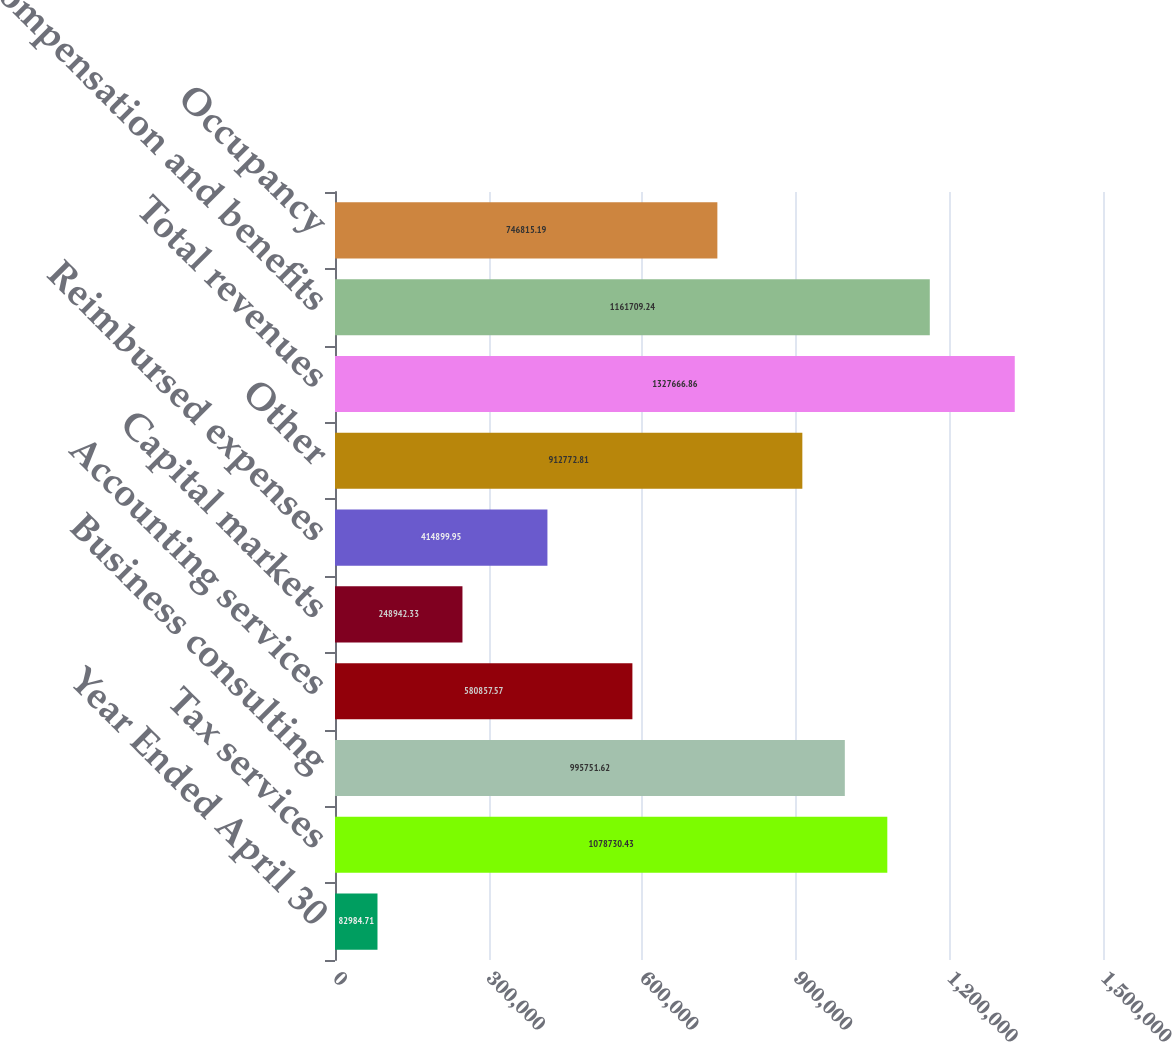Convert chart to OTSL. <chart><loc_0><loc_0><loc_500><loc_500><bar_chart><fcel>Year Ended April 30<fcel>Tax services<fcel>Business consulting<fcel>Accounting services<fcel>Capital markets<fcel>Reimbursed expenses<fcel>Other<fcel>Total revenues<fcel>Compensation and benefits<fcel>Occupancy<nl><fcel>82984.7<fcel>1.07873e+06<fcel>995752<fcel>580858<fcel>248942<fcel>414900<fcel>912773<fcel>1.32767e+06<fcel>1.16171e+06<fcel>746815<nl></chart> 